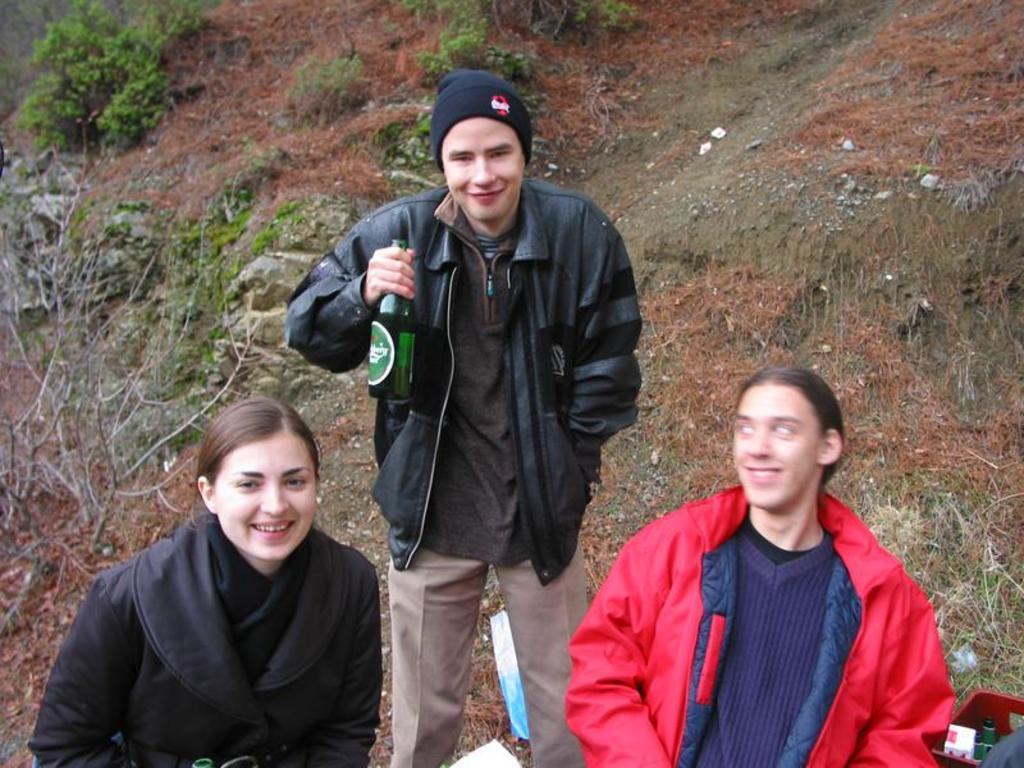Please provide a concise description of this image. In this image there are three persons smiling, and there are some items in a plastic container , a person holding a bottle, and in the background there are plants. 